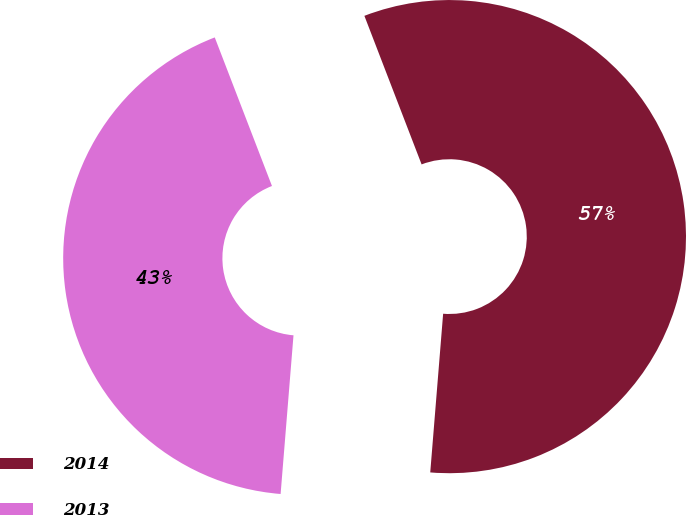<chart> <loc_0><loc_0><loc_500><loc_500><pie_chart><fcel>2014<fcel>2013<nl><fcel>57.14%<fcel>42.86%<nl></chart> 